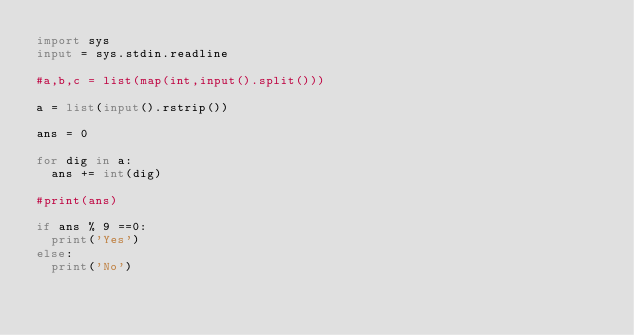<code> <loc_0><loc_0><loc_500><loc_500><_Python_>import sys
input = sys.stdin.readline
 
#a,b,c = list(map(int,input().split()))
 
a = list(input().rstrip())

ans = 0

for dig in a:
  ans += int(dig)
  
#print(ans)
  
if ans % 9 ==0:
  print('Yes')
else:
  print('No')</code> 